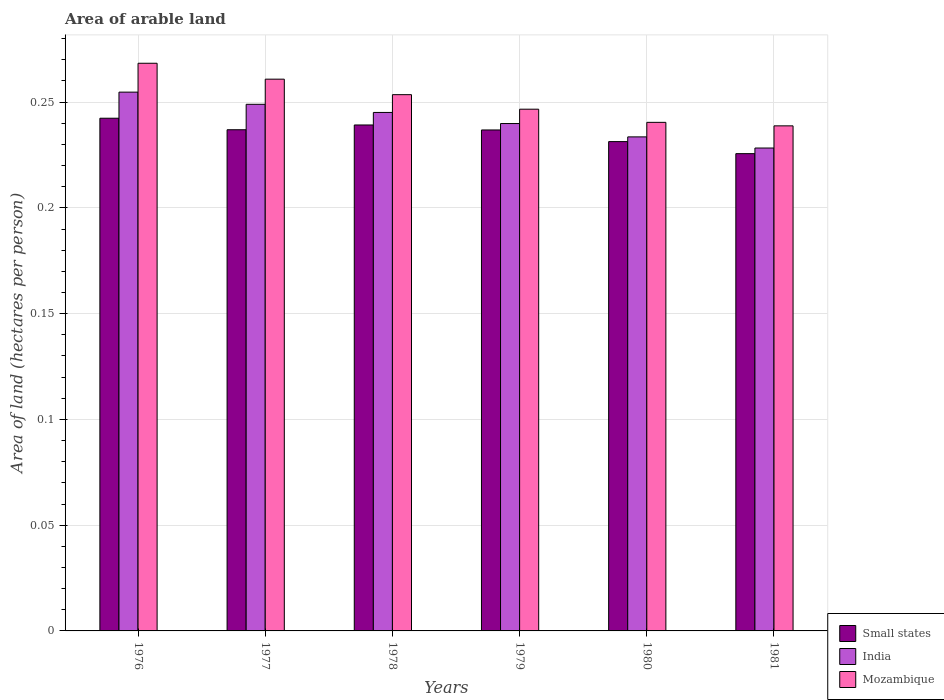How many groups of bars are there?
Make the answer very short. 6. Are the number of bars per tick equal to the number of legend labels?
Your answer should be compact. Yes. Are the number of bars on each tick of the X-axis equal?
Provide a succinct answer. Yes. In how many cases, is the number of bars for a given year not equal to the number of legend labels?
Offer a very short reply. 0. What is the total arable land in Mozambique in 1977?
Provide a succinct answer. 0.26. Across all years, what is the maximum total arable land in Mozambique?
Offer a very short reply. 0.27. Across all years, what is the minimum total arable land in Small states?
Provide a short and direct response. 0.23. In which year was the total arable land in Small states maximum?
Provide a succinct answer. 1976. In which year was the total arable land in India minimum?
Keep it short and to the point. 1981. What is the total total arable land in Small states in the graph?
Provide a short and direct response. 1.41. What is the difference between the total arable land in India in 1976 and that in 1980?
Provide a succinct answer. 0.02. What is the difference between the total arable land in Mozambique in 1977 and the total arable land in India in 1979?
Your answer should be compact. 0.02. What is the average total arable land in India per year?
Your response must be concise. 0.24. In the year 1976, what is the difference between the total arable land in India and total arable land in Small states?
Your answer should be very brief. 0.01. What is the ratio of the total arable land in India in 1976 to that in 1977?
Your answer should be compact. 1.02. Is the total arable land in India in 1977 less than that in 1980?
Offer a terse response. No. What is the difference between the highest and the second highest total arable land in Small states?
Your answer should be very brief. 0. What is the difference between the highest and the lowest total arable land in Mozambique?
Make the answer very short. 0.03. In how many years, is the total arable land in Mozambique greater than the average total arable land in Mozambique taken over all years?
Ensure brevity in your answer.  3. Is the sum of the total arable land in India in 1976 and 1978 greater than the maximum total arable land in Mozambique across all years?
Provide a succinct answer. Yes. What does the 1st bar from the left in 1980 represents?
Ensure brevity in your answer.  Small states. Is it the case that in every year, the sum of the total arable land in India and total arable land in Small states is greater than the total arable land in Mozambique?
Keep it short and to the point. Yes. Are all the bars in the graph horizontal?
Your answer should be compact. No. Are the values on the major ticks of Y-axis written in scientific E-notation?
Your response must be concise. No. Does the graph contain any zero values?
Offer a terse response. No. Does the graph contain grids?
Make the answer very short. Yes. How many legend labels are there?
Offer a very short reply. 3. How are the legend labels stacked?
Make the answer very short. Vertical. What is the title of the graph?
Offer a terse response. Area of arable land. Does "Qatar" appear as one of the legend labels in the graph?
Offer a terse response. No. What is the label or title of the Y-axis?
Provide a short and direct response. Area of land (hectares per person). What is the Area of land (hectares per person) of Small states in 1976?
Keep it short and to the point. 0.24. What is the Area of land (hectares per person) in India in 1976?
Offer a terse response. 0.25. What is the Area of land (hectares per person) of Mozambique in 1976?
Make the answer very short. 0.27. What is the Area of land (hectares per person) of Small states in 1977?
Your answer should be compact. 0.24. What is the Area of land (hectares per person) in India in 1977?
Provide a short and direct response. 0.25. What is the Area of land (hectares per person) in Mozambique in 1977?
Provide a short and direct response. 0.26. What is the Area of land (hectares per person) of Small states in 1978?
Make the answer very short. 0.24. What is the Area of land (hectares per person) in India in 1978?
Your answer should be very brief. 0.25. What is the Area of land (hectares per person) of Mozambique in 1978?
Provide a short and direct response. 0.25. What is the Area of land (hectares per person) in Small states in 1979?
Your answer should be compact. 0.24. What is the Area of land (hectares per person) in India in 1979?
Offer a terse response. 0.24. What is the Area of land (hectares per person) in Mozambique in 1979?
Your answer should be compact. 0.25. What is the Area of land (hectares per person) in Small states in 1980?
Ensure brevity in your answer.  0.23. What is the Area of land (hectares per person) of India in 1980?
Offer a terse response. 0.23. What is the Area of land (hectares per person) of Mozambique in 1980?
Your response must be concise. 0.24. What is the Area of land (hectares per person) in Small states in 1981?
Your response must be concise. 0.23. What is the Area of land (hectares per person) in India in 1981?
Offer a very short reply. 0.23. What is the Area of land (hectares per person) of Mozambique in 1981?
Keep it short and to the point. 0.24. Across all years, what is the maximum Area of land (hectares per person) of Small states?
Keep it short and to the point. 0.24. Across all years, what is the maximum Area of land (hectares per person) in India?
Make the answer very short. 0.25. Across all years, what is the maximum Area of land (hectares per person) in Mozambique?
Ensure brevity in your answer.  0.27. Across all years, what is the minimum Area of land (hectares per person) in Small states?
Keep it short and to the point. 0.23. Across all years, what is the minimum Area of land (hectares per person) of India?
Your response must be concise. 0.23. Across all years, what is the minimum Area of land (hectares per person) in Mozambique?
Your answer should be compact. 0.24. What is the total Area of land (hectares per person) of Small states in the graph?
Give a very brief answer. 1.41. What is the total Area of land (hectares per person) in India in the graph?
Your answer should be compact. 1.45. What is the total Area of land (hectares per person) in Mozambique in the graph?
Ensure brevity in your answer.  1.51. What is the difference between the Area of land (hectares per person) of Small states in 1976 and that in 1977?
Your answer should be compact. 0.01. What is the difference between the Area of land (hectares per person) in India in 1976 and that in 1977?
Ensure brevity in your answer.  0.01. What is the difference between the Area of land (hectares per person) in Mozambique in 1976 and that in 1977?
Make the answer very short. 0.01. What is the difference between the Area of land (hectares per person) in Small states in 1976 and that in 1978?
Ensure brevity in your answer.  0. What is the difference between the Area of land (hectares per person) in India in 1976 and that in 1978?
Your response must be concise. 0.01. What is the difference between the Area of land (hectares per person) of Mozambique in 1976 and that in 1978?
Make the answer very short. 0.01. What is the difference between the Area of land (hectares per person) of Small states in 1976 and that in 1979?
Offer a terse response. 0.01. What is the difference between the Area of land (hectares per person) in India in 1976 and that in 1979?
Ensure brevity in your answer.  0.01. What is the difference between the Area of land (hectares per person) of Mozambique in 1976 and that in 1979?
Offer a terse response. 0.02. What is the difference between the Area of land (hectares per person) of Small states in 1976 and that in 1980?
Your answer should be very brief. 0.01. What is the difference between the Area of land (hectares per person) in India in 1976 and that in 1980?
Offer a terse response. 0.02. What is the difference between the Area of land (hectares per person) in Mozambique in 1976 and that in 1980?
Your answer should be very brief. 0.03. What is the difference between the Area of land (hectares per person) of Small states in 1976 and that in 1981?
Your response must be concise. 0.02. What is the difference between the Area of land (hectares per person) of India in 1976 and that in 1981?
Your response must be concise. 0.03. What is the difference between the Area of land (hectares per person) in Mozambique in 1976 and that in 1981?
Your answer should be very brief. 0.03. What is the difference between the Area of land (hectares per person) of Small states in 1977 and that in 1978?
Offer a very short reply. -0. What is the difference between the Area of land (hectares per person) in India in 1977 and that in 1978?
Make the answer very short. 0. What is the difference between the Area of land (hectares per person) of Mozambique in 1977 and that in 1978?
Ensure brevity in your answer.  0.01. What is the difference between the Area of land (hectares per person) of India in 1977 and that in 1979?
Your answer should be compact. 0.01. What is the difference between the Area of land (hectares per person) of Mozambique in 1977 and that in 1979?
Your answer should be compact. 0.01. What is the difference between the Area of land (hectares per person) of Small states in 1977 and that in 1980?
Your answer should be compact. 0.01. What is the difference between the Area of land (hectares per person) in India in 1977 and that in 1980?
Make the answer very short. 0.02. What is the difference between the Area of land (hectares per person) in Mozambique in 1977 and that in 1980?
Ensure brevity in your answer.  0.02. What is the difference between the Area of land (hectares per person) of Small states in 1977 and that in 1981?
Provide a succinct answer. 0.01. What is the difference between the Area of land (hectares per person) in India in 1977 and that in 1981?
Offer a very short reply. 0.02. What is the difference between the Area of land (hectares per person) of Mozambique in 1977 and that in 1981?
Your answer should be very brief. 0.02. What is the difference between the Area of land (hectares per person) of Small states in 1978 and that in 1979?
Ensure brevity in your answer.  0. What is the difference between the Area of land (hectares per person) in India in 1978 and that in 1979?
Provide a succinct answer. 0.01. What is the difference between the Area of land (hectares per person) in Mozambique in 1978 and that in 1979?
Offer a very short reply. 0.01. What is the difference between the Area of land (hectares per person) in Small states in 1978 and that in 1980?
Your answer should be very brief. 0.01. What is the difference between the Area of land (hectares per person) in India in 1978 and that in 1980?
Ensure brevity in your answer.  0.01. What is the difference between the Area of land (hectares per person) in Mozambique in 1978 and that in 1980?
Provide a short and direct response. 0.01. What is the difference between the Area of land (hectares per person) in Small states in 1978 and that in 1981?
Provide a short and direct response. 0.01. What is the difference between the Area of land (hectares per person) in India in 1978 and that in 1981?
Your answer should be compact. 0.02. What is the difference between the Area of land (hectares per person) of Mozambique in 1978 and that in 1981?
Ensure brevity in your answer.  0.01. What is the difference between the Area of land (hectares per person) in Small states in 1979 and that in 1980?
Provide a short and direct response. 0.01. What is the difference between the Area of land (hectares per person) in India in 1979 and that in 1980?
Make the answer very short. 0.01. What is the difference between the Area of land (hectares per person) in Mozambique in 1979 and that in 1980?
Your answer should be compact. 0.01. What is the difference between the Area of land (hectares per person) of Small states in 1979 and that in 1981?
Keep it short and to the point. 0.01. What is the difference between the Area of land (hectares per person) of India in 1979 and that in 1981?
Keep it short and to the point. 0.01. What is the difference between the Area of land (hectares per person) in Mozambique in 1979 and that in 1981?
Offer a terse response. 0.01. What is the difference between the Area of land (hectares per person) in Small states in 1980 and that in 1981?
Offer a terse response. 0.01. What is the difference between the Area of land (hectares per person) in India in 1980 and that in 1981?
Ensure brevity in your answer.  0.01. What is the difference between the Area of land (hectares per person) of Mozambique in 1980 and that in 1981?
Make the answer very short. 0. What is the difference between the Area of land (hectares per person) of Small states in 1976 and the Area of land (hectares per person) of India in 1977?
Make the answer very short. -0.01. What is the difference between the Area of land (hectares per person) in Small states in 1976 and the Area of land (hectares per person) in Mozambique in 1977?
Ensure brevity in your answer.  -0.02. What is the difference between the Area of land (hectares per person) of India in 1976 and the Area of land (hectares per person) of Mozambique in 1977?
Offer a very short reply. -0.01. What is the difference between the Area of land (hectares per person) of Small states in 1976 and the Area of land (hectares per person) of India in 1978?
Make the answer very short. -0. What is the difference between the Area of land (hectares per person) in Small states in 1976 and the Area of land (hectares per person) in Mozambique in 1978?
Offer a very short reply. -0.01. What is the difference between the Area of land (hectares per person) of India in 1976 and the Area of land (hectares per person) of Mozambique in 1978?
Your answer should be compact. 0. What is the difference between the Area of land (hectares per person) of Small states in 1976 and the Area of land (hectares per person) of India in 1979?
Offer a very short reply. 0. What is the difference between the Area of land (hectares per person) of Small states in 1976 and the Area of land (hectares per person) of Mozambique in 1979?
Provide a short and direct response. -0. What is the difference between the Area of land (hectares per person) of India in 1976 and the Area of land (hectares per person) of Mozambique in 1979?
Ensure brevity in your answer.  0.01. What is the difference between the Area of land (hectares per person) of Small states in 1976 and the Area of land (hectares per person) of India in 1980?
Keep it short and to the point. 0.01. What is the difference between the Area of land (hectares per person) of Small states in 1976 and the Area of land (hectares per person) of Mozambique in 1980?
Give a very brief answer. 0. What is the difference between the Area of land (hectares per person) in India in 1976 and the Area of land (hectares per person) in Mozambique in 1980?
Ensure brevity in your answer.  0.01. What is the difference between the Area of land (hectares per person) of Small states in 1976 and the Area of land (hectares per person) of India in 1981?
Offer a terse response. 0.01. What is the difference between the Area of land (hectares per person) in Small states in 1976 and the Area of land (hectares per person) in Mozambique in 1981?
Make the answer very short. 0. What is the difference between the Area of land (hectares per person) in India in 1976 and the Area of land (hectares per person) in Mozambique in 1981?
Provide a short and direct response. 0.02. What is the difference between the Area of land (hectares per person) in Small states in 1977 and the Area of land (hectares per person) in India in 1978?
Provide a succinct answer. -0.01. What is the difference between the Area of land (hectares per person) in Small states in 1977 and the Area of land (hectares per person) in Mozambique in 1978?
Your answer should be compact. -0.02. What is the difference between the Area of land (hectares per person) in India in 1977 and the Area of land (hectares per person) in Mozambique in 1978?
Offer a very short reply. -0. What is the difference between the Area of land (hectares per person) in Small states in 1977 and the Area of land (hectares per person) in India in 1979?
Your response must be concise. -0. What is the difference between the Area of land (hectares per person) of Small states in 1977 and the Area of land (hectares per person) of Mozambique in 1979?
Offer a very short reply. -0.01. What is the difference between the Area of land (hectares per person) of India in 1977 and the Area of land (hectares per person) of Mozambique in 1979?
Offer a terse response. 0. What is the difference between the Area of land (hectares per person) in Small states in 1977 and the Area of land (hectares per person) in India in 1980?
Your answer should be very brief. 0. What is the difference between the Area of land (hectares per person) in Small states in 1977 and the Area of land (hectares per person) in Mozambique in 1980?
Keep it short and to the point. -0. What is the difference between the Area of land (hectares per person) of India in 1977 and the Area of land (hectares per person) of Mozambique in 1980?
Provide a short and direct response. 0.01. What is the difference between the Area of land (hectares per person) of Small states in 1977 and the Area of land (hectares per person) of India in 1981?
Your answer should be very brief. 0.01. What is the difference between the Area of land (hectares per person) in Small states in 1977 and the Area of land (hectares per person) in Mozambique in 1981?
Your answer should be very brief. -0. What is the difference between the Area of land (hectares per person) of India in 1977 and the Area of land (hectares per person) of Mozambique in 1981?
Your response must be concise. 0.01. What is the difference between the Area of land (hectares per person) in Small states in 1978 and the Area of land (hectares per person) in India in 1979?
Provide a short and direct response. -0. What is the difference between the Area of land (hectares per person) of Small states in 1978 and the Area of land (hectares per person) of Mozambique in 1979?
Make the answer very short. -0.01. What is the difference between the Area of land (hectares per person) in India in 1978 and the Area of land (hectares per person) in Mozambique in 1979?
Offer a terse response. -0. What is the difference between the Area of land (hectares per person) of Small states in 1978 and the Area of land (hectares per person) of India in 1980?
Your answer should be compact. 0.01. What is the difference between the Area of land (hectares per person) in Small states in 1978 and the Area of land (hectares per person) in Mozambique in 1980?
Your response must be concise. -0. What is the difference between the Area of land (hectares per person) of India in 1978 and the Area of land (hectares per person) of Mozambique in 1980?
Offer a very short reply. 0. What is the difference between the Area of land (hectares per person) in Small states in 1978 and the Area of land (hectares per person) in India in 1981?
Your response must be concise. 0.01. What is the difference between the Area of land (hectares per person) in India in 1978 and the Area of land (hectares per person) in Mozambique in 1981?
Give a very brief answer. 0.01. What is the difference between the Area of land (hectares per person) of Small states in 1979 and the Area of land (hectares per person) of India in 1980?
Your response must be concise. 0. What is the difference between the Area of land (hectares per person) of Small states in 1979 and the Area of land (hectares per person) of Mozambique in 1980?
Offer a very short reply. -0. What is the difference between the Area of land (hectares per person) in India in 1979 and the Area of land (hectares per person) in Mozambique in 1980?
Your answer should be compact. -0. What is the difference between the Area of land (hectares per person) of Small states in 1979 and the Area of land (hectares per person) of India in 1981?
Provide a short and direct response. 0.01. What is the difference between the Area of land (hectares per person) of Small states in 1979 and the Area of land (hectares per person) of Mozambique in 1981?
Offer a terse response. -0. What is the difference between the Area of land (hectares per person) in India in 1979 and the Area of land (hectares per person) in Mozambique in 1981?
Your answer should be compact. 0. What is the difference between the Area of land (hectares per person) in Small states in 1980 and the Area of land (hectares per person) in India in 1981?
Keep it short and to the point. 0. What is the difference between the Area of land (hectares per person) of Small states in 1980 and the Area of land (hectares per person) of Mozambique in 1981?
Your answer should be compact. -0.01. What is the difference between the Area of land (hectares per person) of India in 1980 and the Area of land (hectares per person) of Mozambique in 1981?
Your answer should be very brief. -0.01. What is the average Area of land (hectares per person) of Small states per year?
Make the answer very short. 0.24. What is the average Area of land (hectares per person) in India per year?
Provide a short and direct response. 0.24. What is the average Area of land (hectares per person) in Mozambique per year?
Your response must be concise. 0.25. In the year 1976, what is the difference between the Area of land (hectares per person) in Small states and Area of land (hectares per person) in India?
Provide a succinct answer. -0.01. In the year 1976, what is the difference between the Area of land (hectares per person) in Small states and Area of land (hectares per person) in Mozambique?
Your response must be concise. -0.03. In the year 1976, what is the difference between the Area of land (hectares per person) of India and Area of land (hectares per person) of Mozambique?
Give a very brief answer. -0.01. In the year 1977, what is the difference between the Area of land (hectares per person) in Small states and Area of land (hectares per person) in India?
Provide a succinct answer. -0.01. In the year 1977, what is the difference between the Area of land (hectares per person) of Small states and Area of land (hectares per person) of Mozambique?
Offer a terse response. -0.02. In the year 1977, what is the difference between the Area of land (hectares per person) in India and Area of land (hectares per person) in Mozambique?
Keep it short and to the point. -0.01. In the year 1978, what is the difference between the Area of land (hectares per person) in Small states and Area of land (hectares per person) in India?
Your response must be concise. -0.01. In the year 1978, what is the difference between the Area of land (hectares per person) in Small states and Area of land (hectares per person) in Mozambique?
Give a very brief answer. -0.01. In the year 1978, what is the difference between the Area of land (hectares per person) of India and Area of land (hectares per person) of Mozambique?
Offer a very short reply. -0.01. In the year 1979, what is the difference between the Area of land (hectares per person) of Small states and Area of land (hectares per person) of India?
Make the answer very short. -0. In the year 1979, what is the difference between the Area of land (hectares per person) of Small states and Area of land (hectares per person) of Mozambique?
Your answer should be compact. -0.01. In the year 1979, what is the difference between the Area of land (hectares per person) of India and Area of land (hectares per person) of Mozambique?
Offer a very short reply. -0.01. In the year 1980, what is the difference between the Area of land (hectares per person) in Small states and Area of land (hectares per person) in India?
Your answer should be compact. -0. In the year 1980, what is the difference between the Area of land (hectares per person) in Small states and Area of land (hectares per person) in Mozambique?
Ensure brevity in your answer.  -0.01. In the year 1980, what is the difference between the Area of land (hectares per person) in India and Area of land (hectares per person) in Mozambique?
Make the answer very short. -0.01. In the year 1981, what is the difference between the Area of land (hectares per person) of Small states and Area of land (hectares per person) of India?
Provide a succinct answer. -0. In the year 1981, what is the difference between the Area of land (hectares per person) in Small states and Area of land (hectares per person) in Mozambique?
Offer a very short reply. -0.01. In the year 1981, what is the difference between the Area of land (hectares per person) of India and Area of land (hectares per person) of Mozambique?
Your answer should be compact. -0.01. What is the ratio of the Area of land (hectares per person) of Small states in 1976 to that in 1977?
Keep it short and to the point. 1.02. What is the ratio of the Area of land (hectares per person) in India in 1976 to that in 1977?
Provide a succinct answer. 1.02. What is the ratio of the Area of land (hectares per person) of Mozambique in 1976 to that in 1977?
Your answer should be compact. 1.03. What is the ratio of the Area of land (hectares per person) of Small states in 1976 to that in 1978?
Your response must be concise. 1.01. What is the ratio of the Area of land (hectares per person) of India in 1976 to that in 1978?
Give a very brief answer. 1.04. What is the ratio of the Area of land (hectares per person) of Mozambique in 1976 to that in 1978?
Keep it short and to the point. 1.06. What is the ratio of the Area of land (hectares per person) of Small states in 1976 to that in 1979?
Offer a very short reply. 1.02. What is the ratio of the Area of land (hectares per person) of India in 1976 to that in 1979?
Keep it short and to the point. 1.06. What is the ratio of the Area of land (hectares per person) of Mozambique in 1976 to that in 1979?
Offer a very short reply. 1.09. What is the ratio of the Area of land (hectares per person) of Small states in 1976 to that in 1980?
Your answer should be compact. 1.05. What is the ratio of the Area of land (hectares per person) in India in 1976 to that in 1980?
Make the answer very short. 1.09. What is the ratio of the Area of land (hectares per person) in Mozambique in 1976 to that in 1980?
Offer a terse response. 1.12. What is the ratio of the Area of land (hectares per person) of Small states in 1976 to that in 1981?
Your answer should be very brief. 1.07. What is the ratio of the Area of land (hectares per person) of India in 1976 to that in 1981?
Your answer should be very brief. 1.12. What is the ratio of the Area of land (hectares per person) of Mozambique in 1976 to that in 1981?
Provide a succinct answer. 1.12. What is the ratio of the Area of land (hectares per person) in Small states in 1977 to that in 1978?
Your response must be concise. 0.99. What is the ratio of the Area of land (hectares per person) of India in 1977 to that in 1978?
Provide a succinct answer. 1.02. What is the ratio of the Area of land (hectares per person) of Mozambique in 1977 to that in 1978?
Provide a succinct answer. 1.03. What is the ratio of the Area of land (hectares per person) in India in 1977 to that in 1979?
Provide a succinct answer. 1.04. What is the ratio of the Area of land (hectares per person) in Mozambique in 1977 to that in 1979?
Give a very brief answer. 1.06. What is the ratio of the Area of land (hectares per person) of Small states in 1977 to that in 1980?
Provide a short and direct response. 1.02. What is the ratio of the Area of land (hectares per person) in India in 1977 to that in 1980?
Your response must be concise. 1.07. What is the ratio of the Area of land (hectares per person) of Mozambique in 1977 to that in 1980?
Keep it short and to the point. 1.08. What is the ratio of the Area of land (hectares per person) of Small states in 1977 to that in 1981?
Give a very brief answer. 1.05. What is the ratio of the Area of land (hectares per person) in India in 1977 to that in 1981?
Make the answer very short. 1.09. What is the ratio of the Area of land (hectares per person) in Mozambique in 1977 to that in 1981?
Give a very brief answer. 1.09. What is the ratio of the Area of land (hectares per person) in India in 1978 to that in 1979?
Give a very brief answer. 1.02. What is the ratio of the Area of land (hectares per person) in Mozambique in 1978 to that in 1979?
Your answer should be very brief. 1.03. What is the ratio of the Area of land (hectares per person) in Small states in 1978 to that in 1980?
Your answer should be compact. 1.03. What is the ratio of the Area of land (hectares per person) in India in 1978 to that in 1980?
Offer a very short reply. 1.05. What is the ratio of the Area of land (hectares per person) of Mozambique in 1978 to that in 1980?
Keep it short and to the point. 1.05. What is the ratio of the Area of land (hectares per person) in Small states in 1978 to that in 1981?
Offer a terse response. 1.06. What is the ratio of the Area of land (hectares per person) of India in 1978 to that in 1981?
Ensure brevity in your answer.  1.07. What is the ratio of the Area of land (hectares per person) in Mozambique in 1978 to that in 1981?
Give a very brief answer. 1.06. What is the ratio of the Area of land (hectares per person) of Small states in 1979 to that in 1980?
Keep it short and to the point. 1.02. What is the ratio of the Area of land (hectares per person) in India in 1979 to that in 1980?
Give a very brief answer. 1.03. What is the ratio of the Area of land (hectares per person) in Mozambique in 1979 to that in 1980?
Keep it short and to the point. 1.03. What is the ratio of the Area of land (hectares per person) of Small states in 1979 to that in 1981?
Your answer should be very brief. 1.05. What is the ratio of the Area of land (hectares per person) of India in 1979 to that in 1981?
Provide a succinct answer. 1.05. What is the ratio of the Area of land (hectares per person) in Mozambique in 1979 to that in 1981?
Offer a terse response. 1.03. What is the ratio of the Area of land (hectares per person) of Small states in 1980 to that in 1981?
Provide a succinct answer. 1.03. What is the ratio of the Area of land (hectares per person) in India in 1980 to that in 1981?
Make the answer very short. 1.02. What is the ratio of the Area of land (hectares per person) of Mozambique in 1980 to that in 1981?
Keep it short and to the point. 1.01. What is the difference between the highest and the second highest Area of land (hectares per person) in Small states?
Provide a short and direct response. 0. What is the difference between the highest and the second highest Area of land (hectares per person) in India?
Offer a very short reply. 0.01. What is the difference between the highest and the second highest Area of land (hectares per person) of Mozambique?
Ensure brevity in your answer.  0.01. What is the difference between the highest and the lowest Area of land (hectares per person) in Small states?
Provide a succinct answer. 0.02. What is the difference between the highest and the lowest Area of land (hectares per person) in India?
Ensure brevity in your answer.  0.03. What is the difference between the highest and the lowest Area of land (hectares per person) of Mozambique?
Your answer should be very brief. 0.03. 